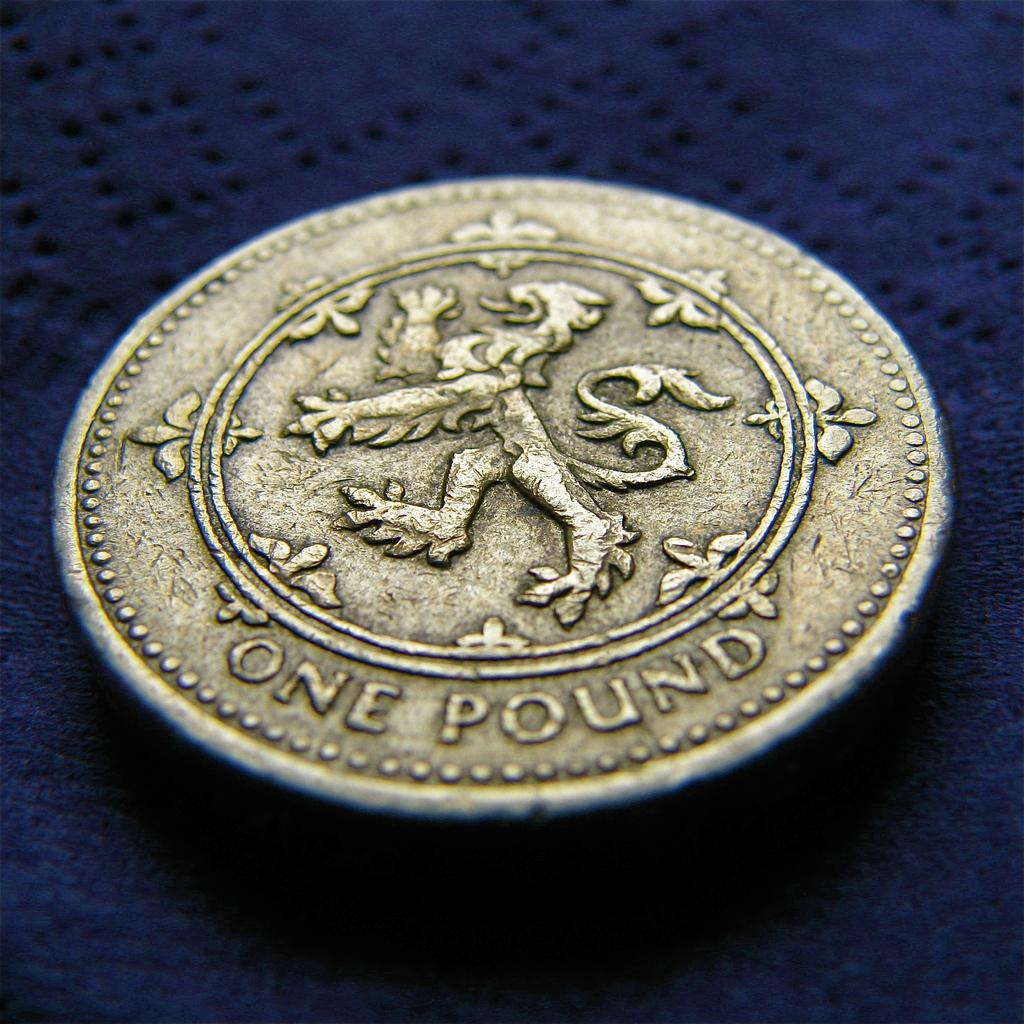<image>
Render a clear and concise summary of the photo. a close up of a One Pound coin with a lion on it 